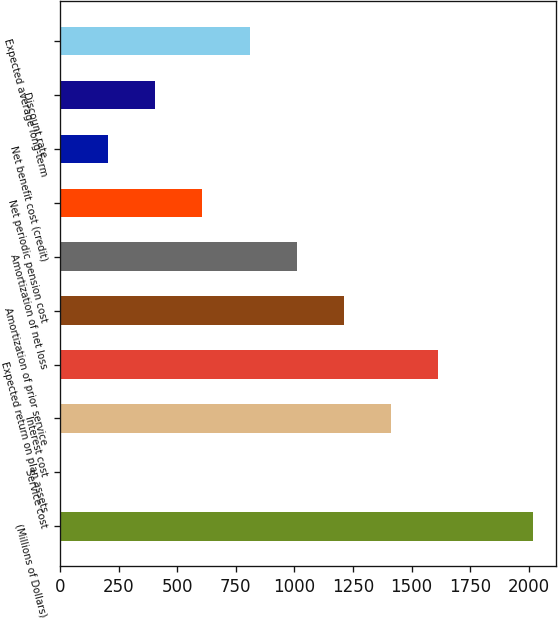<chart> <loc_0><loc_0><loc_500><loc_500><bar_chart><fcel>(Millions of Dollars)<fcel>Service cost<fcel>Interest cost<fcel>Expected return on plan assets<fcel>Amortization of prior service<fcel>Amortization of net loss<fcel>Net periodic pension cost<fcel>Net benefit cost (credit)<fcel>Discount rate<fcel>Expected average long-term<nl><fcel>2018<fcel>2<fcel>1413.2<fcel>1614.8<fcel>1211.6<fcel>1010<fcel>606.8<fcel>203.6<fcel>405.2<fcel>808.4<nl></chart> 